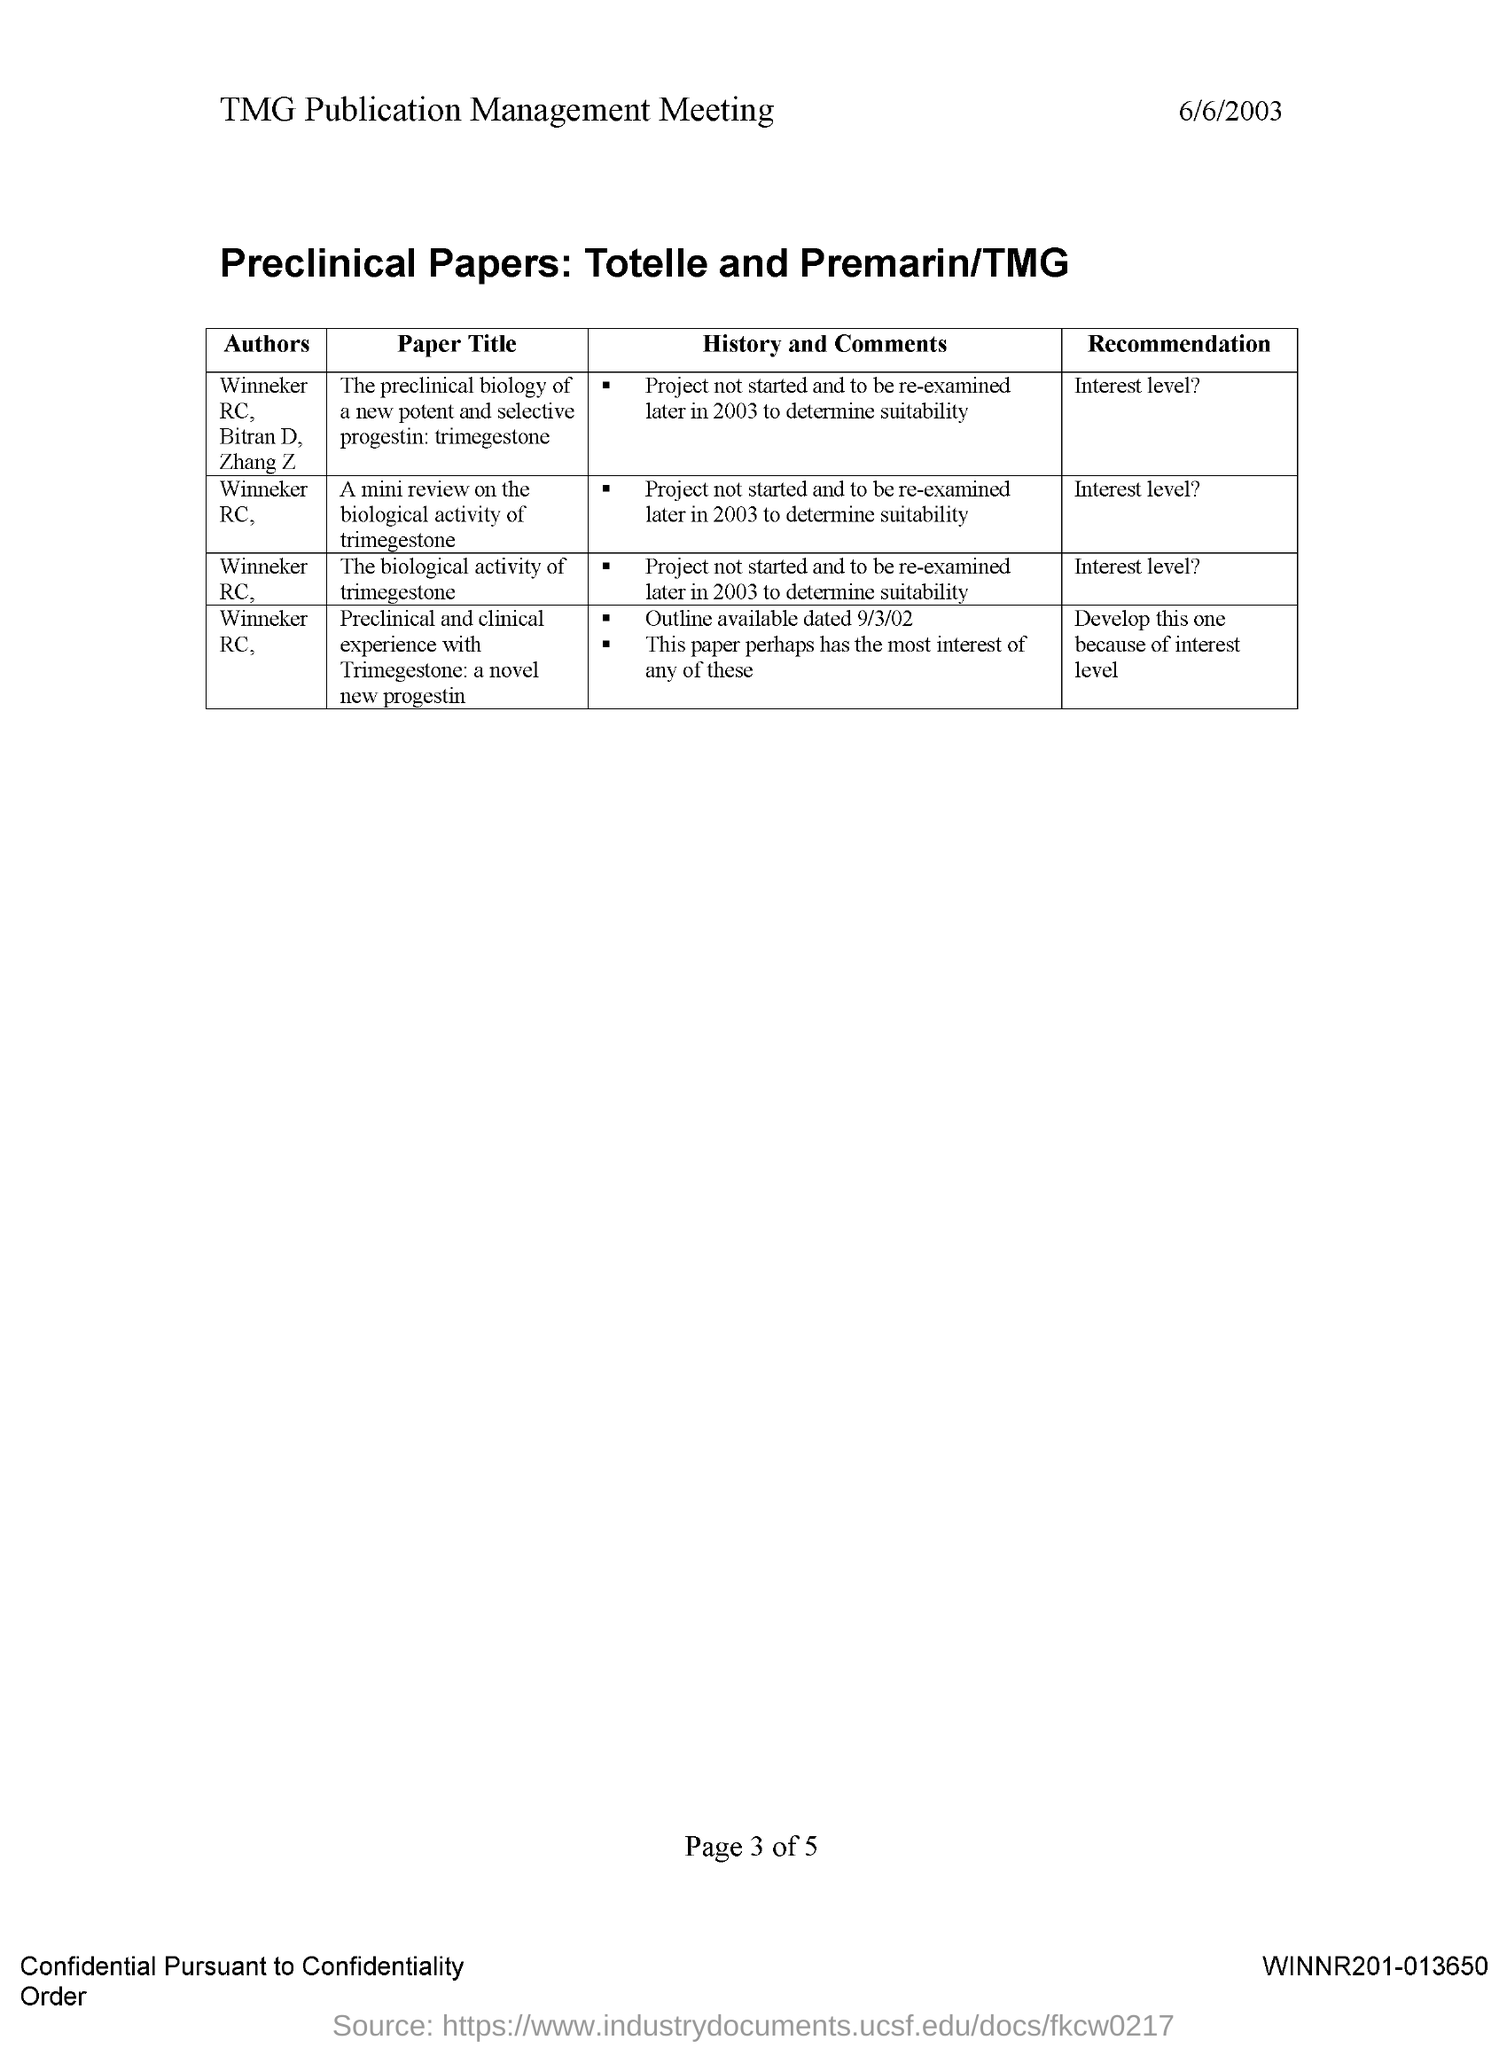Mention a couple of crucial points in this snapshot. The study titled "The biological activity of trimegestone" has been recommended for its interest level. The date mentioned in this document is 6/6/2003. The paper titled "A mini review on the biological activity of trimegestone" was written by Winneker RC,... The article titled "The preclinical biology of a new potent and selective progestin: trimegestone" was written by Winneker RC, Bitran D, and Zhang Z. The paper titled "A mini review on the biological activity of trimegestone" has been recommended for (insert adjective) interest level. 